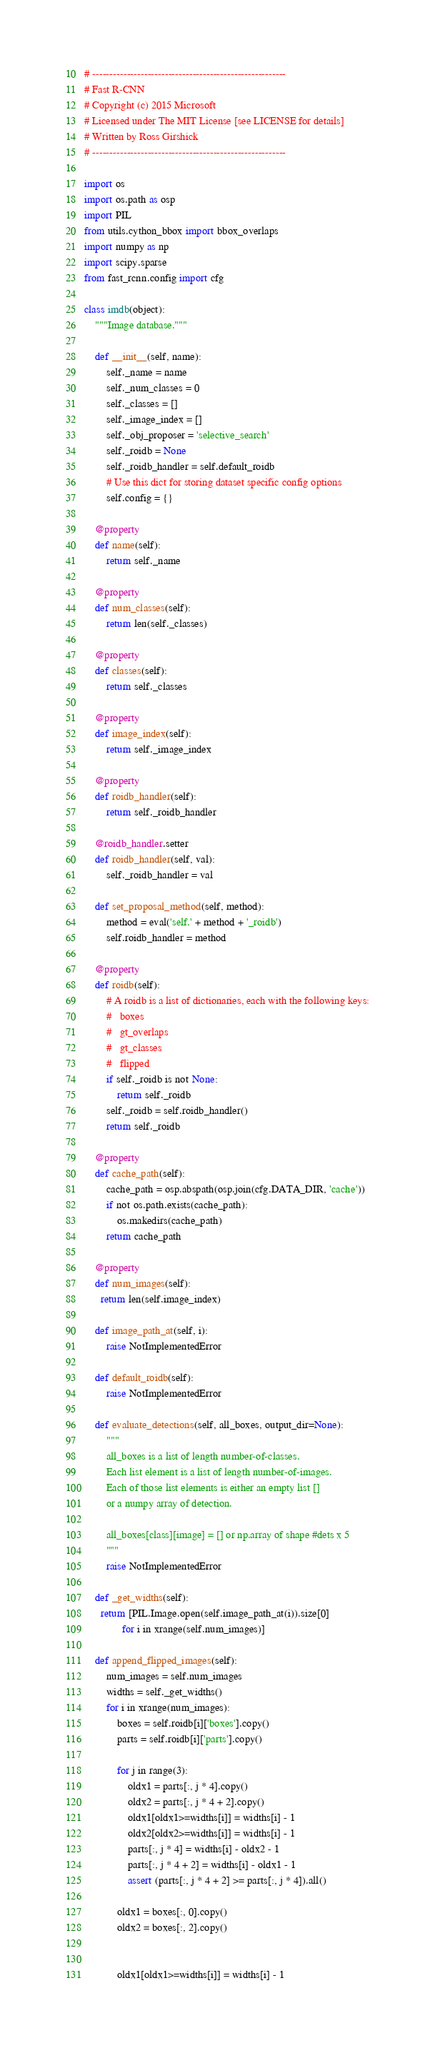<code> <loc_0><loc_0><loc_500><loc_500><_Python_># --------------------------------------------------------
# Fast R-CNN
# Copyright (c) 2015 Microsoft
# Licensed under The MIT License [see LICENSE for details]
# Written by Ross Girshick
# --------------------------------------------------------

import os
import os.path as osp
import PIL
from utils.cython_bbox import bbox_overlaps
import numpy as np
import scipy.sparse
from fast_rcnn.config import cfg

class imdb(object):
    """Image database."""

    def __init__(self, name):
        self._name = name
        self._num_classes = 0
        self._classes = []
        self._image_index = []
        self._obj_proposer = 'selective_search'
        self._roidb = None
        self._roidb_handler = self.default_roidb
        # Use this dict for storing dataset specific config options
        self.config = {}

    @property
    def name(self):
        return self._name

    @property
    def num_classes(self):
        return len(self._classes)

    @property
    def classes(self):
        return self._classes

    @property
    def image_index(self):
        return self._image_index

    @property
    def roidb_handler(self):
        return self._roidb_handler

    @roidb_handler.setter
    def roidb_handler(self, val):
        self._roidb_handler = val

    def set_proposal_method(self, method):
        method = eval('self.' + method + '_roidb')
        self.roidb_handler = method

    @property
    def roidb(self):
        # A roidb is a list of dictionaries, each with the following keys:
        #   boxes
        #   gt_overlaps
        #   gt_classes
        #   flipped
        if self._roidb is not None:
            return self._roidb
        self._roidb = self.roidb_handler()
        return self._roidb

    @property
    def cache_path(self):
        cache_path = osp.abspath(osp.join(cfg.DATA_DIR, 'cache'))
        if not os.path.exists(cache_path):
            os.makedirs(cache_path)
        return cache_path

    @property
    def num_images(self):
      return len(self.image_index)

    def image_path_at(self, i):
        raise NotImplementedError

    def default_roidb(self):
        raise NotImplementedError

    def evaluate_detections(self, all_boxes, output_dir=None):
        """
        all_boxes is a list of length number-of-classes.
        Each list element is a list of length number-of-images.
        Each of those list elements is either an empty list []
        or a numpy array of detection.

        all_boxes[class][image] = [] or np.array of shape #dets x 5
        """
        raise NotImplementedError

    def _get_widths(self):
      return [PIL.Image.open(self.image_path_at(i)).size[0]
              for i in xrange(self.num_images)]

    def append_flipped_images(self):
        num_images = self.num_images
        widths = self._get_widths()
        for i in xrange(num_images):
            boxes = self.roidb[i]['boxes'].copy()
            parts = self.roidb[i]['parts'].copy()

            for j in range(3):
                oldx1 = parts[:, j * 4].copy()
                oldx2 = parts[:, j * 4 + 2].copy()
                oldx1[oldx1>=widths[i]] = widths[i] - 1
                oldx2[oldx2>=widths[i]] = widths[i] - 1
                parts[:, j * 4] = widths[i] - oldx2 - 1
                parts[:, j * 4 + 2] = widths[i] - oldx1 - 1
                assert (parts[:, j * 4 + 2] >= parts[:, j * 4]).all()

            oldx1 = boxes[:, 0].copy()
            oldx2 = boxes[:, 2].copy()


            oldx1[oldx1>=widths[i]] = widths[i] - 1</code> 